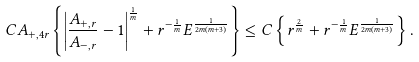<formula> <loc_0><loc_0><loc_500><loc_500>C A _ { + , 4 r } \left \{ \left | \frac { A _ { + , r } } { A _ { - , r } } - 1 \right | ^ { \frac { 1 } { m } } + r ^ { - \frac { 1 } { m } } E ^ { \frac { 1 } { 2 m ( m + 3 ) } } \right \} \leq C \left \{ r ^ { \frac { 2 } { m } } + r ^ { - \frac { 1 } { m } } E ^ { \frac { 1 } { 2 m ( m + 3 ) } } \right \} .</formula> 